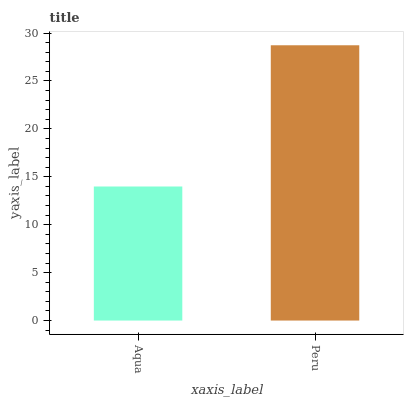Is Peru the minimum?
Answer yes or no. No. Is Peru greater than Aqua?
Answer yes or no. Yes. Is Aqua less than Peru?
Answer yes or no. Yes. Is Aqua greater than Peru?
Answer yes or no. No. Is Peru less than Aqua?
Answer yes or no. No. Is Peru the high median?
Answer yes or no. Yes. Is Aqua the low median?
Answer yes or no. Yes. Is Aqua the high median?
Answer yes or no. No. Is Peru the low median?
Answer yes or no. No. 